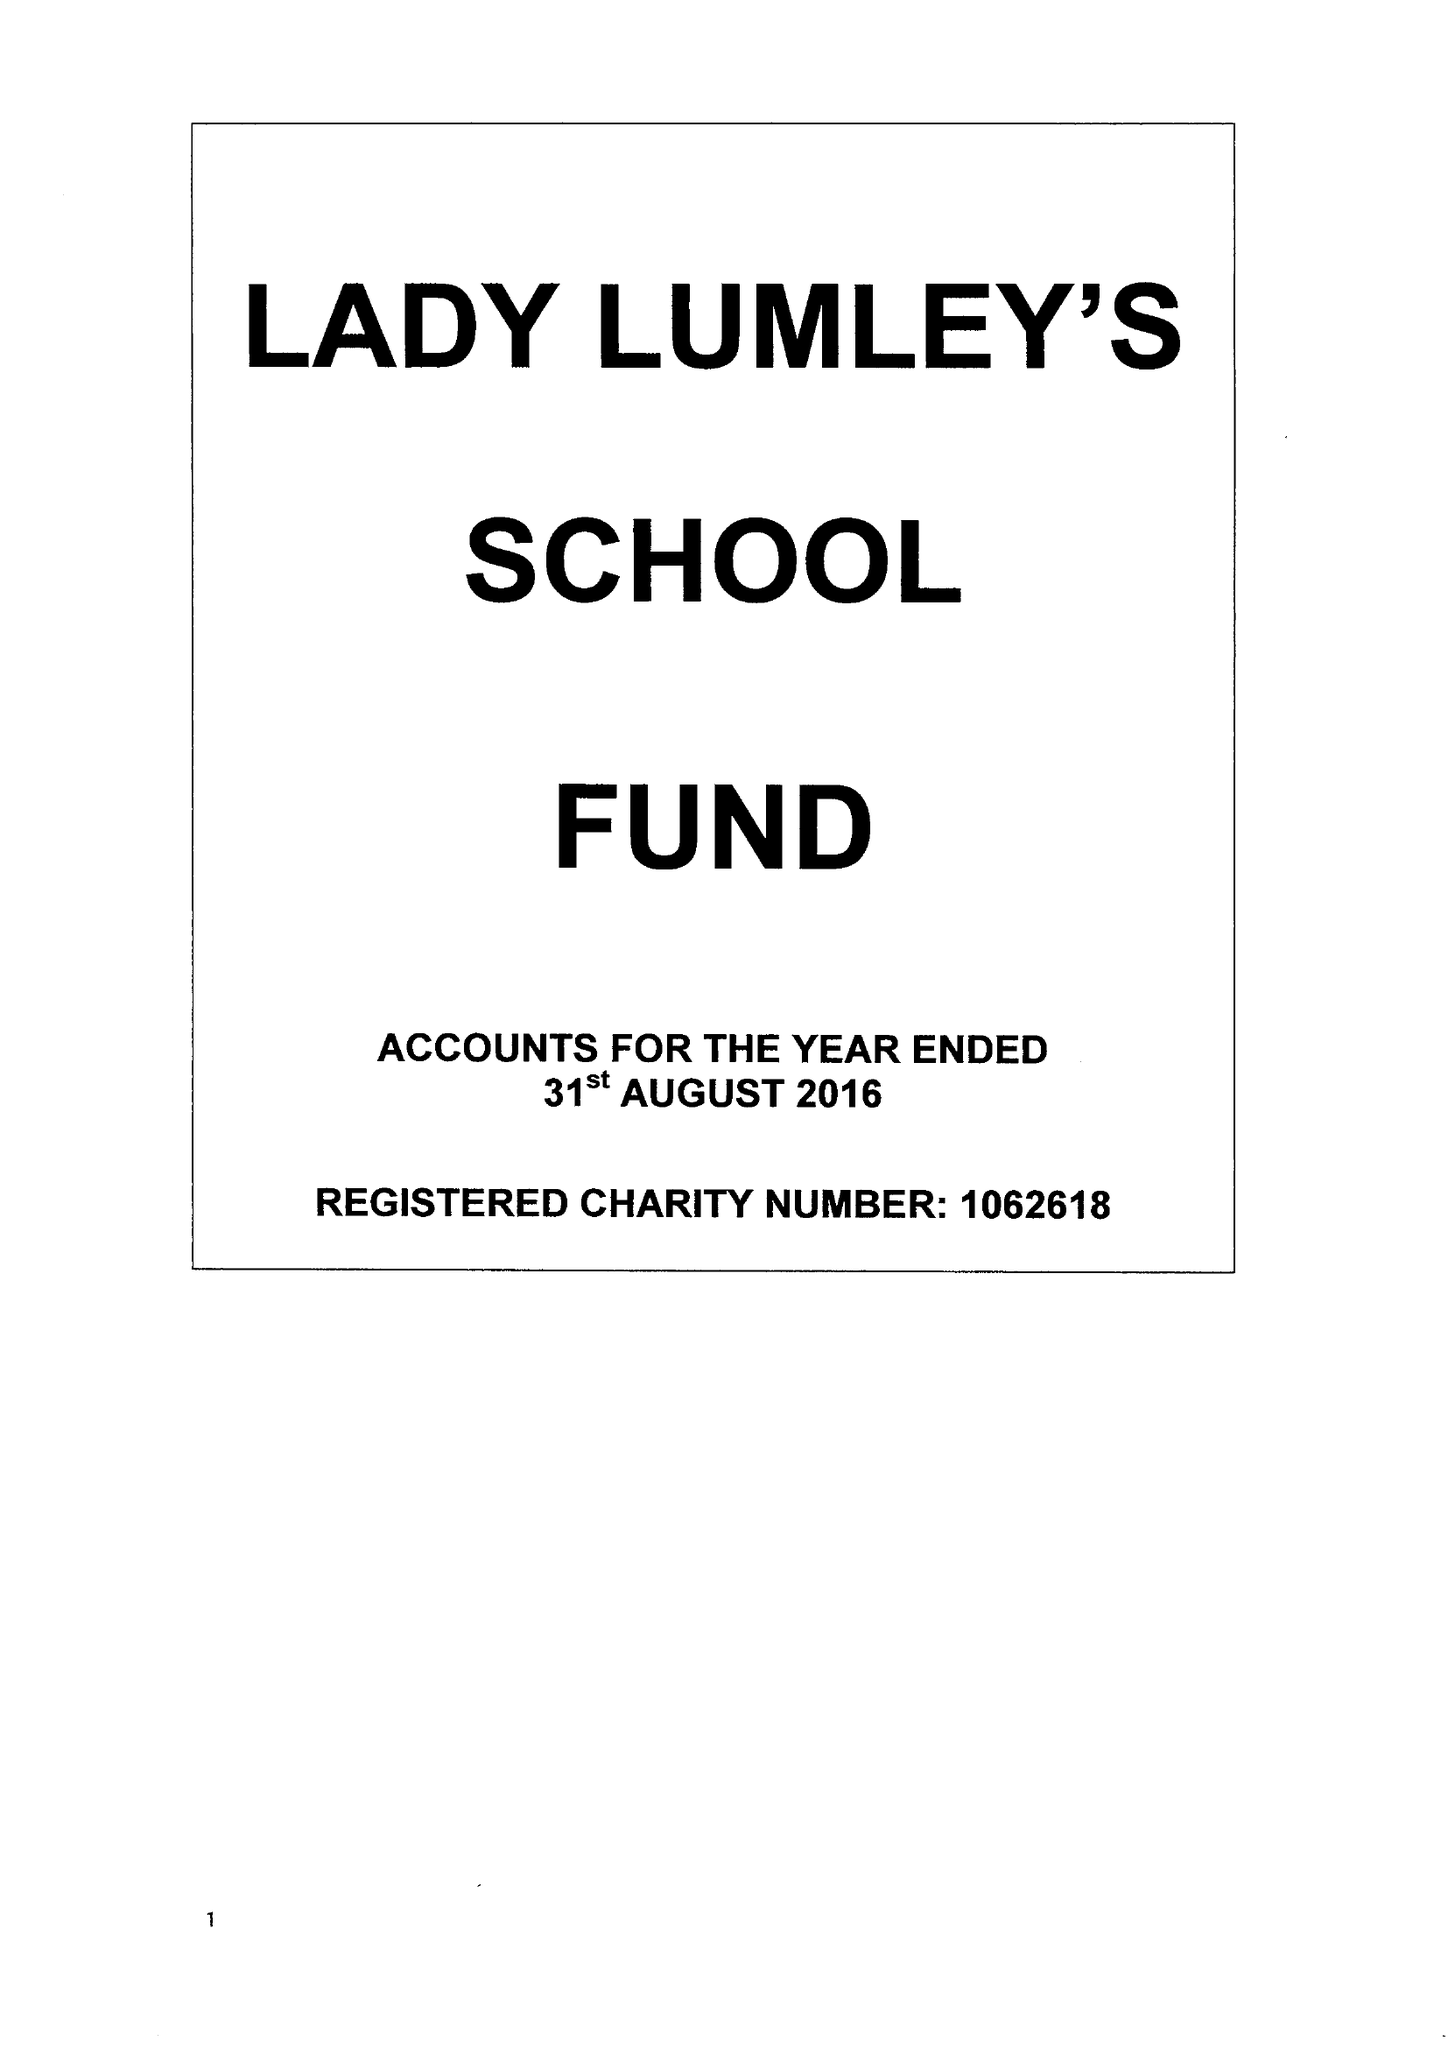What is the value for the spending_annually_in_british_pounds?
Answer the question using a single word or phrase. 162017.00 